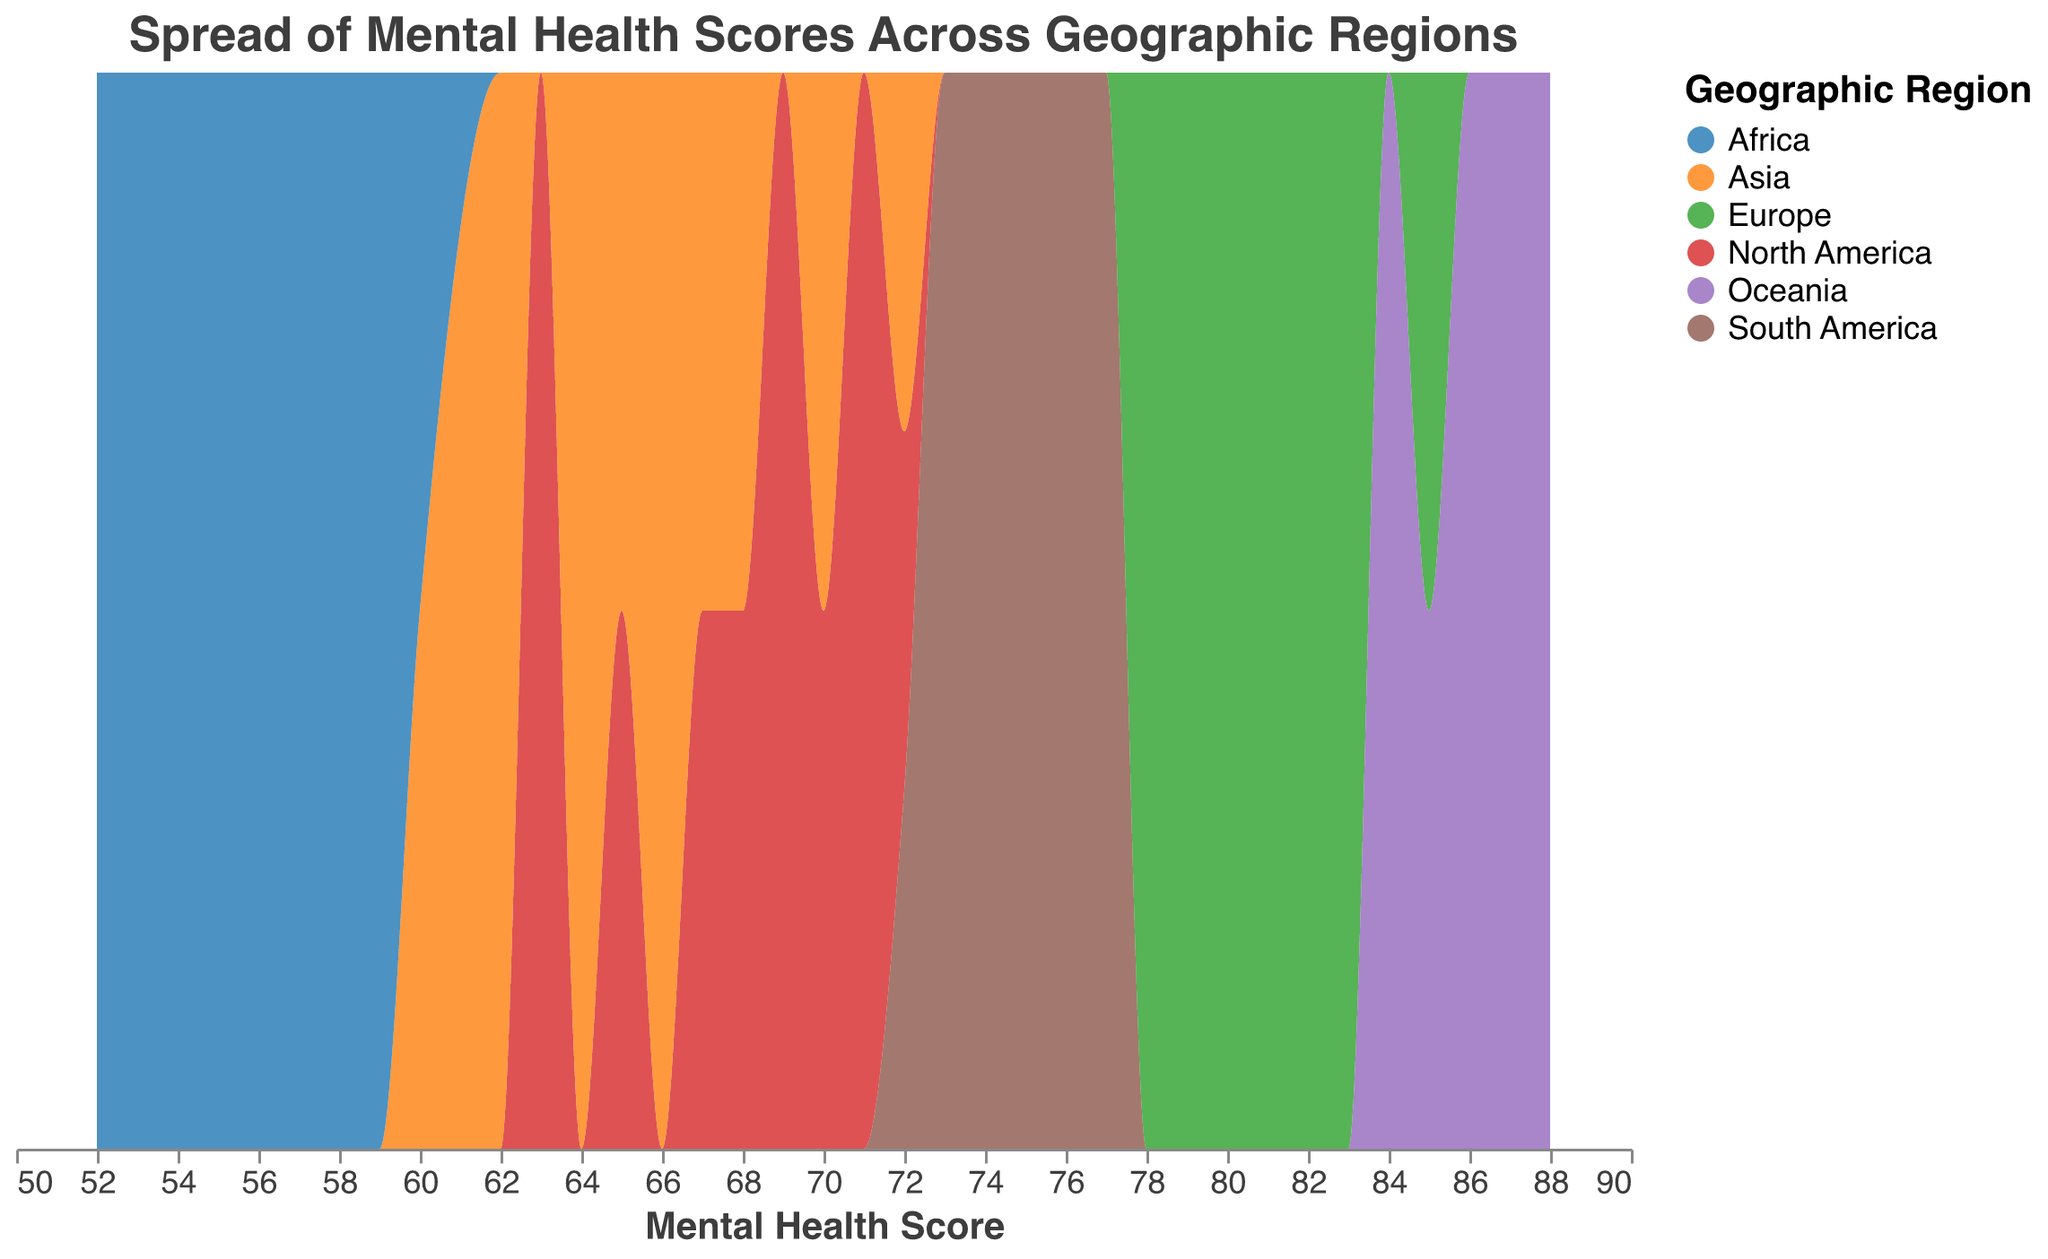What is the title of the figure? The title of the figure is usually at the top and describes what the figure is about. In this case, the title is "Spread of Mental Health Scores Across Geographic Regions" as indicated in the visualization specification.
Answer: Spread of Mental Health Scores Across Geographic Regions What is the range of Mental Health Scores represented in the plot? Look at the x-axis to see the lowest and highest values marked. The x-axis, which represents Mental Health Scores, ranges approximately from 50 to 90.
Answer: 50 to 90 Which region has the highest peak in mental health scores density? Identify the region with the tallest peak on the plot. Visual inspection suggests that Oceania has the highest density peaks because its area reaches the highest point on the y-axis.
Answer: Oceania Which region has the lowest density for Mental Health Scores? Identify the region with the least height in its density area or smallest peak. It seems Africa has the lowest overall peaks, indicating less density in mental health scores compared to other regions.
Answer: Africa How does the spread of Mental Health Scores in Europe compare to that in Asia? Compare the width and height of the density areas for Europe and Asia. Europe shows a density spread more towards the higher end of the Mental Health Scores (78-85), while Asia has scores more spread out and lower (60-72).
Answer: Europe has higher scores and a tighter spread compared to Asia Which region shows the most diverse spread of Mental Health Scores? The diversity of spread can be assessed by looking at the width of the density area. North America appears to have a broader width compared to other regions, indicating a more diverse spread of scores (63-72).
Answer: North America Are there any regions with overlapping Mental Health Scores? Look for areas where density plots of different regions intersect. For example, Europe and Oceania show some overlapping segments in the high range (around 83-86).
Answer: Yes, Europe and Oceania What is the predominant color scheme used in the plot and what does it represent? Identify the color scheme used in the plot and what it encodes. The plot uses a categorical color scheme (similar to "category10") to represent different geographic regions.
Answer: Categorical color scheme for regions Which regions have a peak density around a Mental Health Score of 70? Look for peaks around the score of 70 on the x-axis. Both North America and Asia have peaks around this score, suggesting a higher density of scores around 70 for these regions.
Answer: North America and Asia What does the density normalization imply in this plot? Density normalization means the total area under the curves is scaled to be the same. In this case, the "stack" parameter indicates normalized proportions, so the height of each area's peak reflects relative density while accounting for the total number of cases in each region.
Answer: Reflects relative density while accounting for total cases 